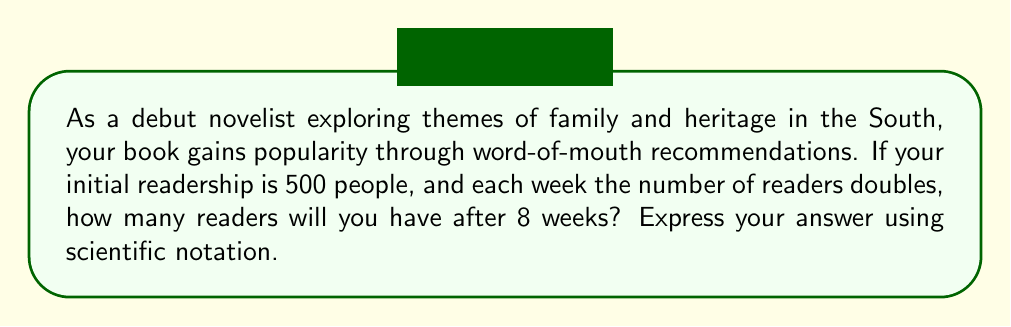Show me your answer to this math problem. To solve this problem, we need to use the exponential growth formula:

$$ A = P(1 + r)^t $$

Where:
$A$ = Final amount
$P$ = Initial amount (principal)
$r$ = Growth rate
$t$ = Time periods

In this case:
$P = 500$ (initial readership)
$r = 1$ (100% growth rate, as the readership doubles each week)
$t = 8$ (weeks)

Let's plug these values into the formula:

$$ A = 500(1 + 1)^8 $$

Simplify:
$$ A = 500(2)^8 $$

Now, let's calculate $2^8$:
$$ 2^8 = 256 $$

So, our equation becomes:
$$ A = 500 \times 256 = 128,000 $$

To express this in scientific notation, we move the decimal point 5 places to the left:

$$ 128,000 = 1.28 \times 10^5 $$

Therefore, after 8 weeks, you will have $1.28 \times 10^5$ readers.
Answer: $1.28 \times 10^5$ readers 